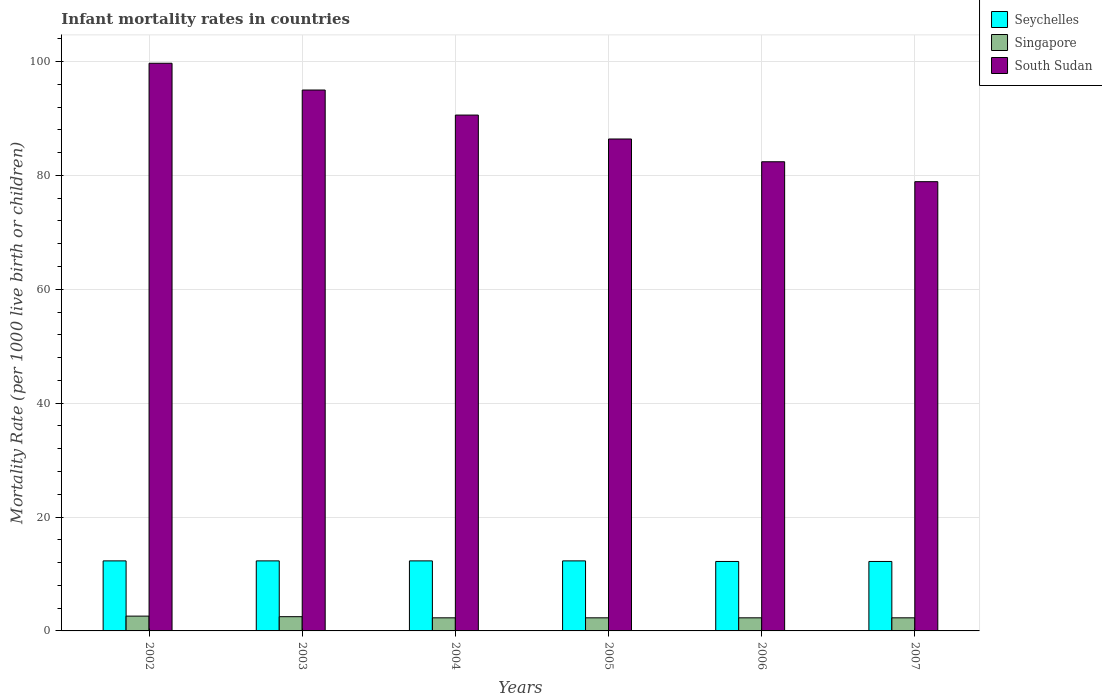How many different coloured bars are there?
Make the answer very short. 3. How many bars are there on the 3rd tick from the right?
Provide a short and direct response. 3. In how many cases, is the number of bars for a given year not equal to the number of legend labels?
Keep it short and to the point. 0. What is the infant mortality rate in Singapore in 2006?
Your answer should be very brief. 2.3. In which year was the infant mortality rate in South Sudan minimum?
Provide a short and direct response. 2007. What is the total infant mortality rate in South Sudan in the graph?
Provide a short and direct response. 533. What is the difference between the infant mortality rate in Singapore in 2003 and the infant mortality rate in Seychelles in 2006?
Offer a very short reply. -9.7. What is the average infant mortality rate in Seychelles per year?
Your answer should be compact. 12.27. In the year 2006, what is the difference between the infant mortality rate in Seychelles and infant mortality rate in Singapore?
Give a very brief answer. 9.9. In how many years, is the infant mortality rate in Seychelles greater than 52?
Your answer should be compact. 0. What is the ratio of the infant mortality rate in South Sudan in 2004 to that in 2006?
Provide a succinct answer. 1.1. Is the infant mortality rate in Singapore in 2003 less than that in 2004?
Keep it short and to the point. No. What is the difference between the highest and the second highest infant mortality rate in Singapore?
Offer a terse response. 0.1. What is the difference between the highest and the lowest infant mortality rate in Singapore?
Provide a succinct answer. 0.3. What does the 3rd bar from the left in 2003 represents?
Offer a very short reply. South Sudan. What does the 1st bar from the right in 2003 represents?
Offer a very short reply. South Sudan. Is it the case that in every year, the sum of the infant mortality rate in Singapore and infant mortality rate in South Sudan is greater than the infant mortality rate in Seychelles?
Provide a succinct answer. Yes. How many bars are there?
Offer a terse response. 18. Where does the legend appear in the graph?
Make the answer very short. Top right. How many legend labels are there?
Give a very brief answer. 3. What is the title of the graph?
Provide a succinct answer. Infant mortality rates in countries. Does "Lesotho" appear as one of the legend labels in the graph?
Provide a short and direct response. No. What is the label or title of the Y-axis?
Offer a very short reply. Mortality Rate (per 1000 live birth or children). What is the Mortality Rate (per 1000 live birth or children) in South Sudan in 2002?
Ensure brevity in your answer.  99.7. What is the Mortality Rate (per 1000 live birth or children) in Seychelles in 2003?
Your response must be concise. 12.3. What is the Mortality Rate (per 1000 live birth or children) of South Sudan in 2003?
Make the answer very short. 95. What is the Mortality Rate (per 1000 live birth or children) of Singapore in 2004?
Ensure brevity in your answer.  2.3. What is the Mortality Rate (per 1000 live birth or children) of South Sudan in 2004?
Provide a succinct answer. 90.6. What is the Mortality Rate (per 1000 live birth or children) of Seychelles in 2005?
Your answer should be compact. 12.3. What is the Mortality Rate (per 1000 live birth or children) of Singapore in 2005?
Offer a very short reply. 2.3. What is the Mortality Rate (per 1000 live birth or children) in South Sudan in 2005?
Your answer should be very brief. 86.4. What is the Mortality Rate (per 1000 live birth or children) of Singapore in 2006?
Make the answer very short. 2.3. What is the Mortality Rate (per 1000 live birth or children) of South Sudan in 2006?
Give a very brief answer. 82.4. What is the Mortality Rate (per 1000 live birth or children) of South Sudan in 2007?
Offer a terse response. 78.9. Across all years, what is the maximum Mortality Rate (per 1000 live birth or children) in South Sudan?
Offer a very short reply. 99.7. Across all years, what is the minimum Mortality Rate (per 1000 live birth or children) of Seychelles?
Ensure brevity in your answer.  12.2. Across all years, what is the minimum Mortality Rate (per 1000 live birth or children) in Singapore?
Offer a terse response. 2.3. Across all years, what is the minimum Mortality Rate (per 1000 live birth or children) in South Sudan?
Make the answer very short. 78.9. What is the total Mortality Rate (per 1000 live birth or children) of Seychelles in the graph?
Your answer should be compact. 73.6. What is the total Mortality Rate (per 1000 live birth or children) in South Sudan in the graph?
Provide a succinct answer. 533. What is the difference between the Mortality Rate (per 1000 live birth or children) of Seychelles in 2002 and that in 2003?
Offer a very short reply. 0. What is the difference between the Mortality Rate (per 1000 live birth or children) of South Sudan in 2002 and that in 2003?
Offer a very short reply. 4.7. What is the difference between the Mortality Rate (per 1000 live birth or children) in South Sudan in 2002 and that in 2004?
Offer a very short reply. 9.1. What is the difference between the Mortality Rate (per 1000 live birth or children) in South Sudan in 2002 and that in 2005?
Keep it short and to the point. 13.3. What is the difference between the Mortality Rate (per 1000 live birth or children) in Singapore in 2002 and that in 2006?
Offer a very short reply. 0.3. What is the difference between the Mortality Rate (per 1000 live birth or children) of Seychelles in 2002 and that in 2007?
Your response must be concise. 0.1. What is the difference between the Mortality Rate (per 1000 live birth or children) in Singapore in 2002 and that in 2007?
Your response must be concise. 0.3. What is the difference between the Mortality Rate (per 1000 live birth or children) in South Sudan in 2002 and that in 2007?
Give a very brief answer. 20.8. What is the difference between the Mortality Rate (per 1000 live birth or children) in Singapore in 2003 and that in 2004?
Your answer should be compact. 0.2. What is the difference between the Mortality Rate (per 1000 live birth or children) of South Sudan in 2003 and that in 2004?
Your answer should be very brief. 4.4. What is the difference between the Mortality Rate (per 1000 live birth or children) in Seychelles in 2003 and that in 2005?
Offer a terse response. 0. What is the difference between the Mortality Rate (per 1000 live birth or children) in Seychelles in 2003 and that in 2006?
Offer a very short reply. 0.1. What is the difference between the Mortality Rate (per 1000 live birth or children) of Singapore in 2003 and that in 2006?
Offer a very short reply. 0.2. What is the difference between the Mortality Rate (per 1000 live birth or children) in South Sudan in 2003 and that in 2006?
Give a very brief answer. 12.6. What is the difference between the Mortality Rate (per 1000 live birth or children) of Seychelles in 2003 and that in 2007?
Give a very brief answer. 0.1. What is the difference between the Mortality Rate (per 1000 live birth or children) in Singapore in 2003 and that in 2007?
Offer a very short reply. 0.2. What is the difference between the Mortality Rate (per 1000 live birth or children) in South Sudan in 2003 and that in 2007?
Your response must be concise. 16.1. What is the difference between the Mortality Rate (per 1000 live birth or children) in Singapore in 2004 and that in 2005?
Provide a succinct answer. 0. What is the difference between the Mortality Rate (per 1000 live birth or children) of Seychelles in 2004 and that in 2006?
Your answer should be compact. 0.1. What is the difference between the Mortality Rate (per 1000 live birth or children) in Singapore in 2004 and that in 2006?
Provide a short and direct response. 0. What is the difference between the Mortality Rate (per 1000 live birth or children) of Singapore in 2004 and that in 2007?
Offer a terse response. 0. What is the difference between the Mortality Rate (per 1000 live birth or children) of South Sudan in 2004 and that in 2007?
Your answer should be very brief. 11.7. What is the difference between the Mortality Rate (per 1000 live birth or children) in South Sudan in 2005 and that in 2006?
Your response must be concise. 4. What is the difference between the Mortality Rate (per 1000 live birth or children) of Seychelles in 2005 and that in 2007?
Keep it short and to the point. 0.1. What is the difference between the Mortality Rate (per 1000 live birth or children) in Singapore in 2005 and that in 2007?
Your answer should be very brief. 0. What is the difference between the Mortality Rate (per 1000 live birth or children) of Seychelles in 2002 and the Mortality Rate (per 1000 live birth or children) of South Sudan in 2003?
Your answer should be compact. -82.7. What is the difference between the Mortality Rate (per 1000 live birth or children) in Singapore in 2002 and the Mortality Rate (per 1000 live birth or children) in South Sudan in 2003?
Provide a short and direct response. -92.4. What is the difference between the Mortality Rate (per 1000 live birth or children) in Seychelles in 2002 and the Mortality Rate (per 1000 live birth or children) in Singapore in 2004?
Ensure brevity in your answer.  10. What is the difference between the Mortality Rate (per 1000 live birth or children) in Seychelles in 2002 and the Mortality Rate (per 1000 live birth or children) in South Sudan in 2004?
Give a very brief answer. -78.3. What is the difference between the Mortality Rate (per 1000 live birth or children) in Singapore in 2002 and the Mortality Rate (per 1000 live birth or children) in South Sudan in 2004?
Ensure brevity in your answer.  -88. What is the difference between the Mortality Rate (per 1000 live birth or children) in Seychelles in 2002 and the Mortality Rate (per 1000 live birth or children) in Singapore in 2005?
Offer a terse response. 10. What is the difference between the Mortality Rate (per 1000 live birth or children) of Seychelles in 2002 and the Mortality Rate (per 1000 live birth or children) of South Sudan in 2005?
Provide a succinct answer. -74.1. What is the difference between the Mortality Rate (per 1000 live birth or children) in Singapore in 2002 and the Mortality Rate (per 1000 live birth or children) in South Sudan in 2005?
Ensure brevity in your answer.  -83.8. What is the difference between the Mortality Rate (per 1000 live birth or children) of Seychelles in 2002 and the Mortality Rate (per 1000 live birth or children) of Singapore in 2006?
Provide a short and direct response. 10. What is the difference between the Mortality Rate (per 1000 live birth or children) of Seychelles in 2002 and the Mortality Rate (per 1000 live birth or children) of South Sudan in 2006?
Make the answer very short. -70.1. What is the difference between the Mortality Rate (per 1000 live birth or children) in Singapore in 2002 and the Mortality Rate (per 1000 live birth or children) in South Sudan in 2006?
Keep it short and to the point. -79.8. What is the difference between the Mortality Rate (per 1000 live birth or children) of Seychelles in 2002 and the Mortality Rate (per 1000 live birth or children) of South Sudan in 2007?
Offer a very short reply. -66.6. What is the difference between the Mortality Rate (per 1000 live birth or children) in Singapore in 2002 and the Mortality Rate (per 1000 live birth or children) in South Sudan in 2007?
Give a very brief answer. -76.3. What is the difference between the Mortality Rate (per 1000 live birth or children) in Seychelles in 2003 and the Mortality Rate (per 1000 live birth or children) in Singapore in 2004?
Your answer should be very brief. 10. What is the difference between the Mortality Rate (per 1000 live birth or children) of Seychelles in 2003 and the Mortality Rate (per 1000 live birth or children) of South Sudan in 2004?
Your response must be concise. -78.3. What is the difference between the Mortality Rate (per 1000 live birth or children) of Singapore in 2003 and the Mortality Rate (per 1000 live birth or children) of South Sudan in 2004?
Keep it short and to the point. -88.1. What is the difference between the Mortality Rate (per 1000 live birth or children) in Seychelles in 2003 and the Mortality Rate (per 1000 live birth or children) in Singapore in 2005?
Ensure brevity in your answer.  10. What is the difference between the Mortality Rate (per 1000 live birth or children) of Seychelles in 2003 and the Mortality Rate (per 1000 live birth or children) of South Sudan in 2005?
Offer a very short reply. -74.1. What is the difference between the Mortality Rate (per 1000 live birth or children) in Singapore in 2003 and the Mortality Rate (per 1000 live birth or children) in South Sudan in 2005?
Provide a short and direct response. -83.9. What is the difference between the Mortality Rate (per 1000 live birth or children) in Seychelles in 2003 and the Mortality Rate (per 1000 live birth or children) in South Sudan in 2006?
Your answer should be compact. -70.1. What is the difference between the Mortality Rate (per 1000 live birth or children) of Singapore in 2003 and the Mortality Rate (per 1000 live birth or children) of South Sudan in 2006?
Your response must be concise. -79.9. What is the difference between the Mortality Rate (per 1000 live birth or children) in Seychelles in 2003 and the Mortality Rate (per 1000 live birth or children) in South Sudan in 2007?
Provide a succinct answer. -66.6. What is the difference between the Mortality Rate (per 1000 live birth or children) of Singapore in 2003 and the Mortality Rate (per 1000 live birth or children) of South Sudan in 2007?
Offer a terse response. -76.4. What is the difference between the Mortality Rate (per 1000 live birth or children) of Seychelles in 2004 and the Mortality Rate (per 1000 live birth or children) of Singapore in 2005?
Provide a short and direct response. 10. What is the difference between the Mortality Rate (per 1000 live birth or children) in Seychelles in 2004 and the Mortality Rate (per 1000 live birth or children) in South Sudan in 2005?
Your answer should be compact. -74.1. What is the difference between the Mortality Rate (per 1000 live birth or children) in Singapore in 2004 and the Mortality Rate (per 1000 live birth or children) in South Sudan in 2005?
Make the answer very short. -84.1. What is the difference between the Mortality Rate (per 1000 live birth or children) of Seychelles in 2004 and the Mortality Rate (per 1000 live birth or children) of South Sudan in 2006?
Your answer should be very brief. -70.1. What is the difference between the Mortality Rate (per 1000 live birth or children) of Singapore in 2004 and the Mortality Rate (per 1000 live birth or children) of South Sudan in 2006?
Make the answer very short. -80.1. What is the difference between the Mortality Rate (per 1000 live birth or children) in Seychelles in 2004 and the Mortality Rate (per 1000 live birth or children) in South Sudan in 2007?
Offer a very short reply. -66.6. What is the difference between the Mortality Rate (per 1000 live birth or children) in Singapore in 2004 and the Mortality Rate (per 1000 live birth or children) in South Sudan in 2007?
Provide a succinct answer. -76.6. What is the difference between the Mortality Rate (per 1000 live birth or children) in Seychelles in 2005 and the Mortality Rate (per 1000 live birth or children) in South Sudan in 2006?
Your response must be concise. -70.1. What is the difference between the Mortality Rate (per 1000 live birth or children) of Singapore in 2005 and the Mortality Rate (per 1000 live birth or children) of South Sudan in 2006?
Your answer should be compact. -80.1. What is the difference between the Mortality Rate (per 1000 live birth or children) of Seychelles in 2005 and the Mortality Rate (per 1000 live birth or children) of Singapore in 2007?
Give a very brief answer. 10. What is the difference between the Mortality Rate (per 1000 live birth or children) of Seychelles in 2005 and the Mortality Rate (per 1000 live birth or children) of South Sudan in 2007?
Your response must be concise. -66.6. What is the difference between the Mortality Rate (per 1000 live birth or children) of Singapore in 2005 and the Mortality Rate (per 1000 live birth or children) of South Sudan in 2007?
Provide a short and direct response. -76.6. What is the difference between the Mortality Rate (per 1000 live birth or children) of Seychelles in 2006 and the Mortality Rate (per 1000 live birth or children) of South Sudan in 2007?
Keep it short and to the point. -66.7. What is the difference between the Mortality Rate (per 1000 live birth or children) of Singapore in 2006 and the Mortality Rate (per 1000 live birth or children) of South Sudan in 2007?
Keep it short and to the point. -76.6. What is the average Mortality Rate (per 1000 live birth or children) of Seychelles per year?
Give a very brief answer. 12.27. What is the average Mortality Rate (per 1000 live birth or children) of Singapore per year?
Provide a short and direct response. 2.38. What is the average Mortality Rate (per 1000 live birth or children) in South Sudan per year?
Give a very brief answer. 88.83. In the year 2002, what is the difference between the Mortality Rate (per 1000 live birth or children) of Seychelles and Mortality Rate (per 1000 live birth or children) of South Sudan?
Your response must be concise. -87.4. In the year 2002, what is the difference between the Mortality Rate (per 1000 live birth or children) in Singapore and Mortality Rate (per 1000 live birth or children) in South Sudan?
Provide a succinct answer. -97.1. In the year 2003, what is the difference between the Mortality Rate (per 1000 live birth or children) in Seychelles and Mortality Rate (per 1000 live birth or children) in Singapore?
Your response must be concise. 9.8. In the year 2003, what is the difference between the Mortality Rate (per 1000 live birth or children) of Seychelles and Mortality Rate (per 1000 live birth or children) of South Sudan?
Your answer should be compact. -82.7. In the year 2003, what is the difference between the Mortality Rate (per 1000 live birth or children) in Singapore and Mortality Rate (per 1000 live birth or children) in South Sudan?
Ensure brevity in your answer.  -92.5. In the year 2004, what is the difference between the Mortality Rate (per 1000 live birth or children) in Seychelles and Mortality Rate (per 1000 live birth or children) in South Sudan?
Your answer should be very brief. -78.3. In the year 2004, what is the difference between the Mortality Rate (per 1000 live birth or children) of Singapore and Mortality Rate (per 1000 live birth or children) of South Sudan?
Keep it short and to the point. -88.3. In the year 2005, what is the difference between the Mortality Rate (per 1000 live birth or children) of Seychelles and Mortality Rate (per 1000 live birth or children) of Singapore?
Provide a short and direct response. 10. In the year 2005, what is the difference between the Mortality Rate (per 1000 live birth or children) in Seychelles and Mortality Rate (per 1000 live birth or children) in South Sudan?
Offer a terse response. -74.1. In the year 2005, what is the difference between the Mortality Rate (per 1000 live birth or children) in Singapore and Mortality Rate (per 1000 live birth or children) in South Sudan?
Give a very brief answer. -84.1. In the year 2006, what is the difference between the Mortality Rate (per 1000 live birth or children) in Seychelles and Mortality Rate (per 1000 live birth or children) in South Sudan?
Offer a very short reply. -70.2. In the year 2006, what is the difference between the Mortality Rate (per 1000 live birth or children) of Singapore and Mortality Rate (per 1000 live birth or children) of South Sudan?
Keep it short and to the point. -80.1. In the year 2007, what is the difference between the Mortality Rate (per 1000 live birth or children) of Seychelles and Mortality Rate (per 1000 live birth or children) of South Sudan?
Your response must be concise. -66.7. In the year 2007, what is the difference between the Mortality Rate (per 1000 live birth or children) in Singapore and Mortality Rate (per 1000 live birth or children) in South Sudan?
Make the answer very short. -76.6. What is the ratio of the Mortality Rate (per 1000 live birth or children) in South Sudan in 2002 to that in 2003?
Provide a succinct answer. 1.05. What is the ratio of the Mortality Rate (per 1000 live birth or children) of Seychelles in 2002 to that in 2004?
Your answer should be very brief. 1. What is the ratio of the Mortality Rate (per 1000 live birth or children) in Singapore in 2002 to that in 2004?
Make the answer very short. 1.13. What is the ratio of the Mortality Rate (per 1000 live birth or children) in South Sudan in 2002 to that in 2004?
Offer a terse response. 1.1. What is the ratio of the Mortality Rate (per 1000 live birth or children) in Singapore in 2002 to that in 2005?
Provide a succinct answer. 1.13. What is the ratio of the Mortality Rate (per 1000 live birth or children) in South Sudan in 2002 to that in 2005?
Your answer should be very brief. 1.15. What is the ratio of the Mortality Rate (per 1000 live birth or children) in Seychelles in 2002 to that in 2006?
Your response must be concise. 1.01. What is the ratio of the Mortality Rate (per 1000 live birth or children) of Singapore in 2002 to that in 2006?
Keep it short and to the point. 1.13. What is the ratio of the Mortality Rate (per 1000 live birth or children) in South Sudan in 2002 to that in 2006?
Provide a short and direct response. 1.21. What is the ratio of the Mortality Rate (per 1000 live birth or children) in Seychelles in 2002 to that in 2007?
Keep it short and to the point. 1.01. What is the ratio of the Mortality Rate (per 1000 live birth or children) in Singapore in 2002 to that in 2007?
Ensure brevity in your answer.  1.13. What is the ratio of the Mortality Rate (per 1000 live birth or children) of South Sudan in 2002 to that in 2007?
Provide a succinct answer. 1.26. What is the ratio of the Mortality Rate (per 1000 live birth or children) in Seychelles in 2003 to that in 2004?
Make the answer very short. 1. What is the ratio of the Mortality Rate (per 1000 live birth or children) in Singapore in 2003 to that in 2004?
Your answer should be very brief. 1.09. What is the ratio of the Mortality Rate (per 1000 live birth or children) in South Sudan in 2003 to that in 2004?
Provide a short and direct response. 1.05. What is the ratio of the Mortality Rate (per 1000 live birth or children) in Seychelles in 2003 to that in 2005?
Make the answer very short. 1. What is the ratio of the Mortality Rate (per 1000 live birth or children) in Singapore in 2003 to that in 2005?
Your answer should be compact. 1.09. What is the ratio of the Mortality Rate (per 1000 live birth or children) in South Sudan in 2003 to that in 2005?
Ensure brevity in your answer.  1.1. What is the ratio of the Mortality Rate (per 1000 live birth or children) of Seychelles in 2003 to that in 2006?
Your answer should be very brief. 1.01. What is the ratio of the Mortality Rate (per 1000 live birth or children) of Singapore in 2003 to that in 2006?
Make the answer very short. 1.09. What is the ratio of the Mortality Rate (per 1000 live birth or children) of South Sudan in 2003 to that in 2006?
Keep it short and to the point. 1.15. What is the ratio of the Mortality Rate (per 1000 live birth or children) in Seychelles in 2003 to that in 2007?
Ensure brevity in your answer.  1.01. What is the ratio of the Mortality Rate (per 1000 live birth or children) in Singapore in 2003 to that in 2007?
Provide a short and direct response. 1.09. What is the ratio of the Mortality Rate (per 1000 live birth or children) in South Sudan in 2003 to that in 2007?
Keep it short and to the point. 1.2. What is the ratio of the Mortality Rate (per 1000 live birth or children) of South Sudan in 2004 to that in 2005?
Your answer should be very brief. 1.05. What is the ratio of the Mortality Rate (per 1000 live birth or children) in Seychelles in 2004 to that in 2006?
Make the answer very short. 1.01. What is the ratio of the Mortality Rate (per 1000 live birth or children) of South Sudan in 2004 to that in 2006?
Your answer should be compact. 1.1. What is the ratio of the Mortality Rate (per 1000 live birth or children) in Seychelles in 2004 to that in 2007?
Keep it short and to the point. 1.01. What is the ratio of the Mortality Rate (per 1000 live birth or children) in South Sudan in 2004 to that in 2007?
Give a very brief answer. 1.15. What is the ratio of the Mortality Rate (per 1000 live birth or children) in Seychelles in 2005 to that in 2006?
Offer a terse response. 1.01. What is the ratio of the Mortality Rate (per 1000 live birth or children) of Singapore in 2005 to that in 2006?
Give a very brief answer. 1. What is the ratio of the Mortality Rate (per 1000 live birth or children) of South Sudan in 2005 to that in 2006?
Give a very brief answer. 1.05. What is the ratio of the Mortality Rate (per 1000 live birth or children) in Seychelles in 2005 to that in 2007?
Offer a very short reply. 1.01. What is the ratio of the Mortality Rate (per 1000 live birth or children) of Singapore in 2005 to that in 2007?
Provide a succinct answer. 1. What is the ratio of the Mortality Rate (per 1000 live birth or children) of South Sudan in 2005 to that in 2007?
Offer a very short reply. 1.1. What is the ratio of the Mortality Rate (per 1000 live birth or children) in Singapore in 2006 to that in 2007?
Your response must be concise. 1. What is the ratio of the Mortality Rate (per 1000 live birth or children) of South Sudan in 2006 to that in 2007?
Your answer should be very brief. 1.04. What is the difference between the highest and the second highest Mortality Rate (per 1000 live birth or children) of South Sudan?
Make the answer very short. 4.7. What is the difference between the highest and the lowest Mortality Rate (per 1000 live birth or children) of Seychelles?
Give a very brief answer. 0.1. What is the difference between the highest and the lowest Mortality Rate (per 1000 live birth or children) in South Sudan?
Keep it short and to the point. 20.8. 